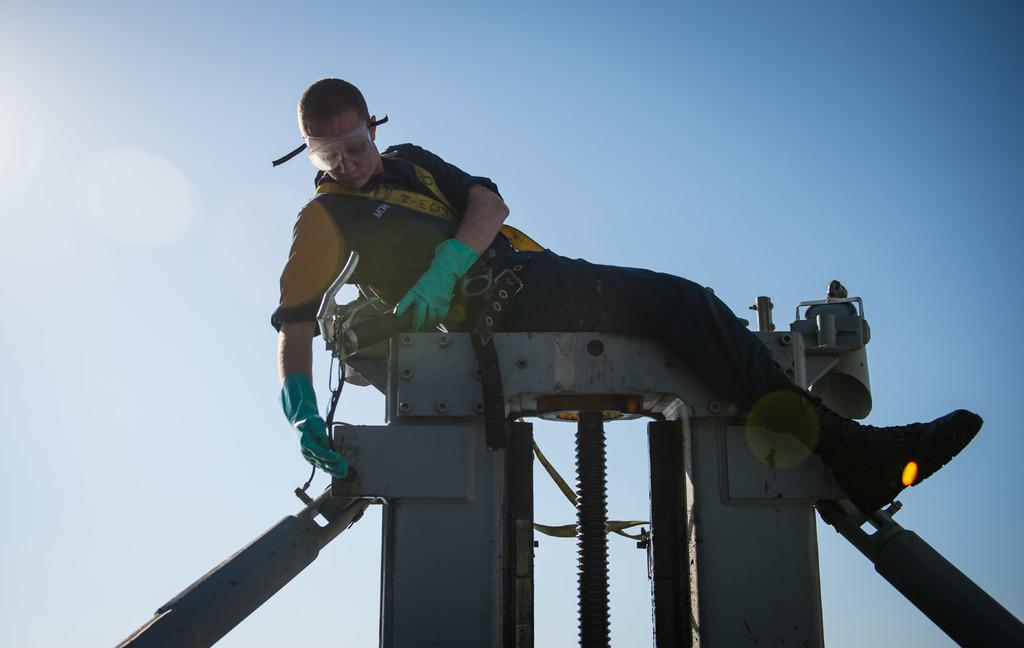What is the main subject of the image? The main subject of the image is a worker. Where is the worker located in the image? The worker is on top of an iron equipment. What can be seen in the background of the image? There is sky visible in the background of the image. What type of country is depicted in the image? There is no country depicted in the image; it features a worker on top of an iron equipment with sky visible in the background. What angle is the worker positioned at in the image? The angle at which the worker is positioned cannot be determined from the image alone, as it only provides a two-dimensional representation. 